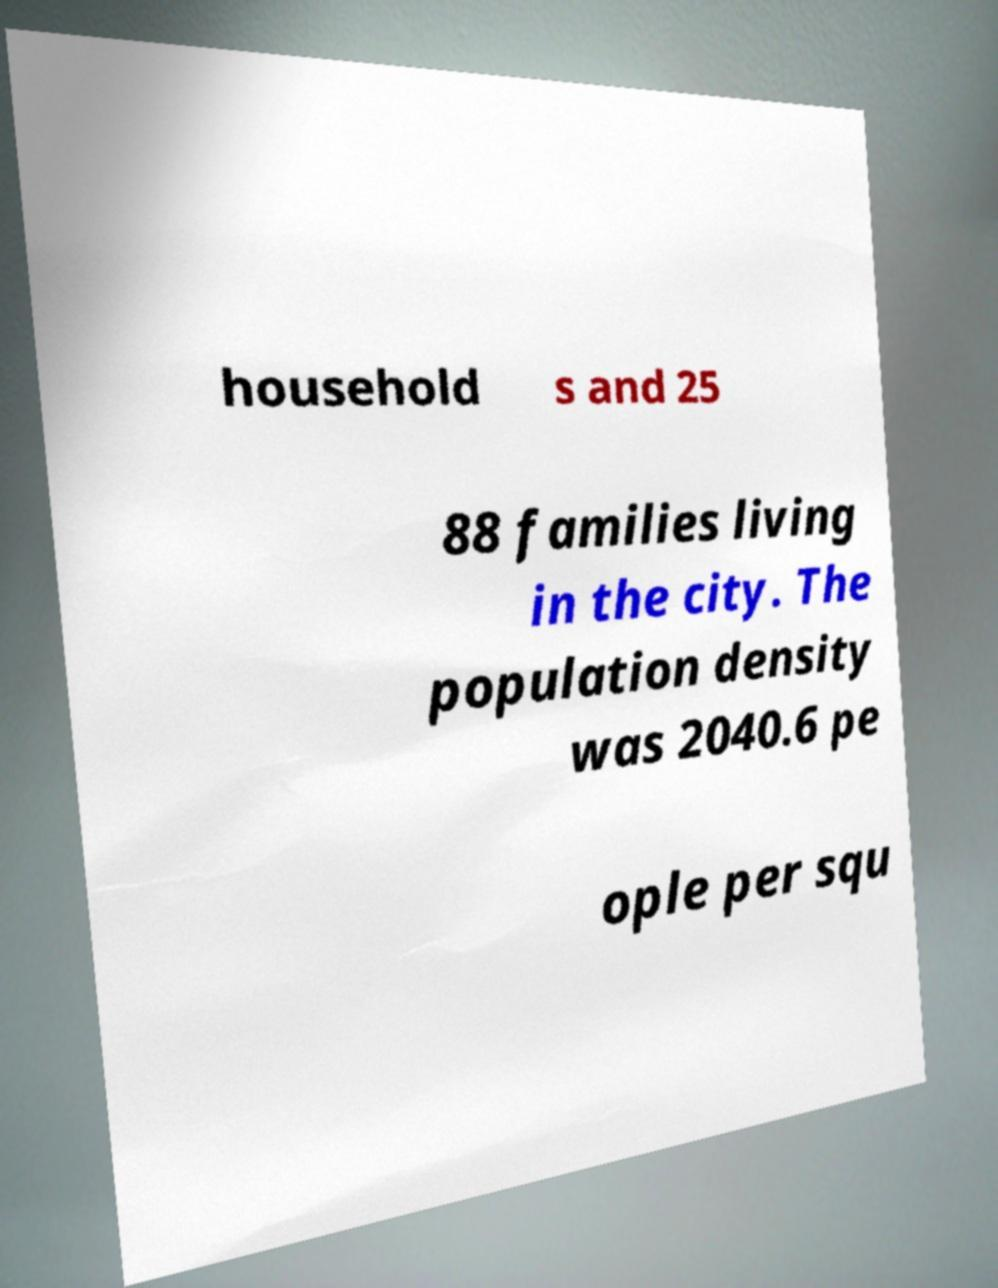Can you accurately transcribe the text from the provided image for me? household s and 25 88 families living in the city. The population density was 2040.6 pe ople per squ 